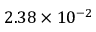Convert formula to latex. <formula><loc_0><loc_0><loc_500><loc_500>2 . 3 8 \times 1 0 ^ { - 2 }</formula> 